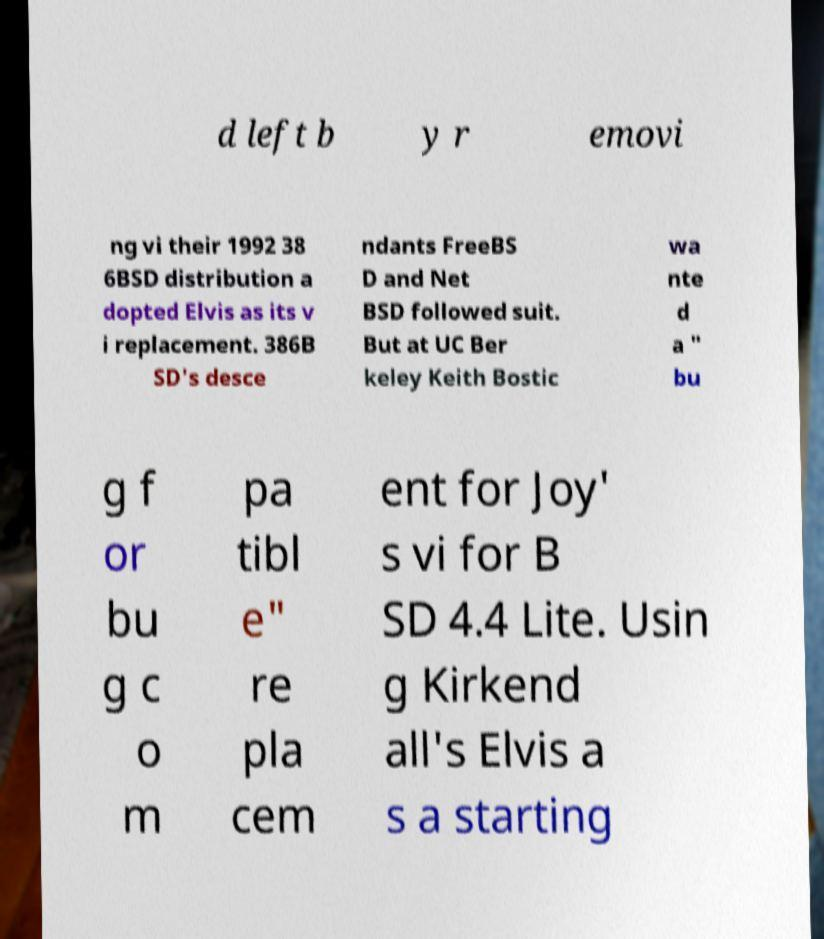I need the written content from this picture converted into text. Can you do that? d left b y r emovi ng vi their 1992 38 6BSD distribution a dopted Elvis as its v i replacement. 386B SD's desce ndants FreeBS D and Net BSD followed suit. But at UC Ber keley Keith Bostic wa nte d a " bu g f or bu g c o m pa tibl e" re pla cem ent for Joy' s vi for B SD 4.4 Lite. Usin g Kirkend all's Elvis a s a starting 